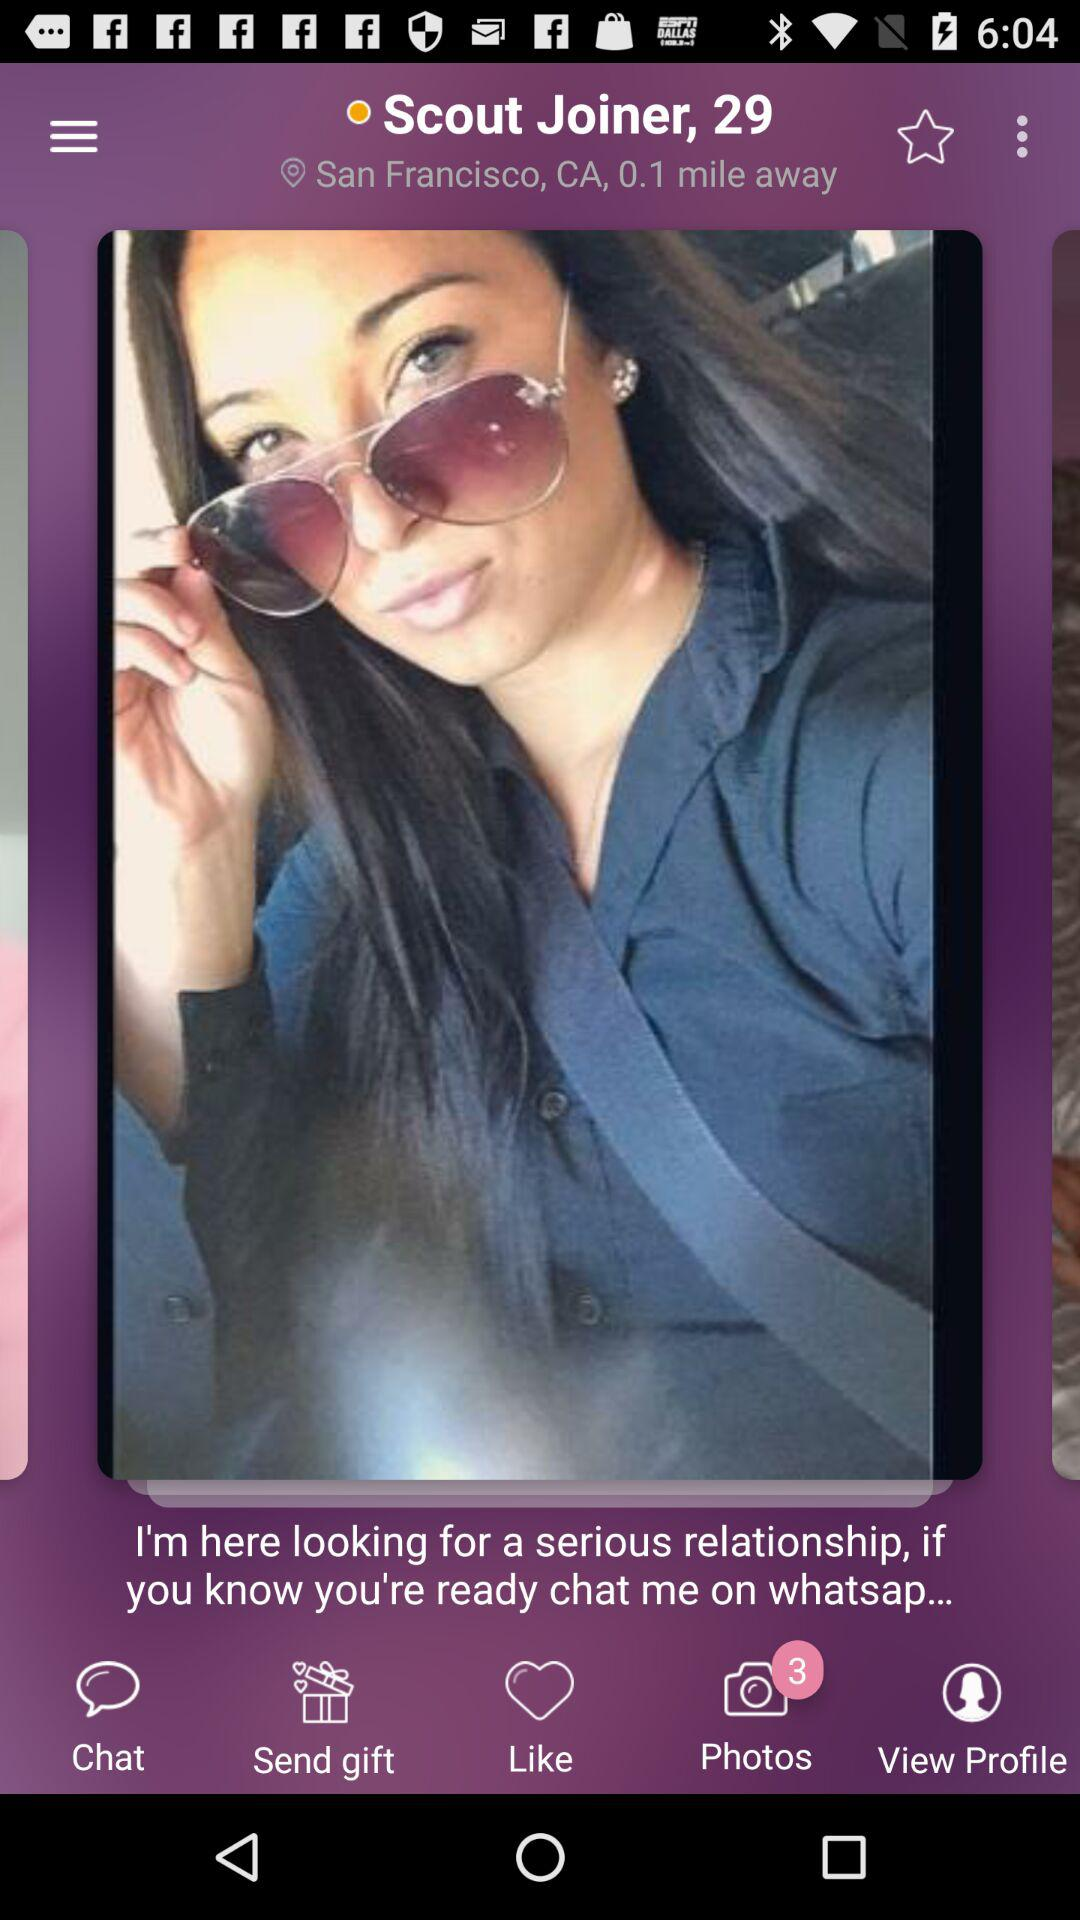How many unseen photos are in the "Photos" folder? There are 3 unseen photos. 